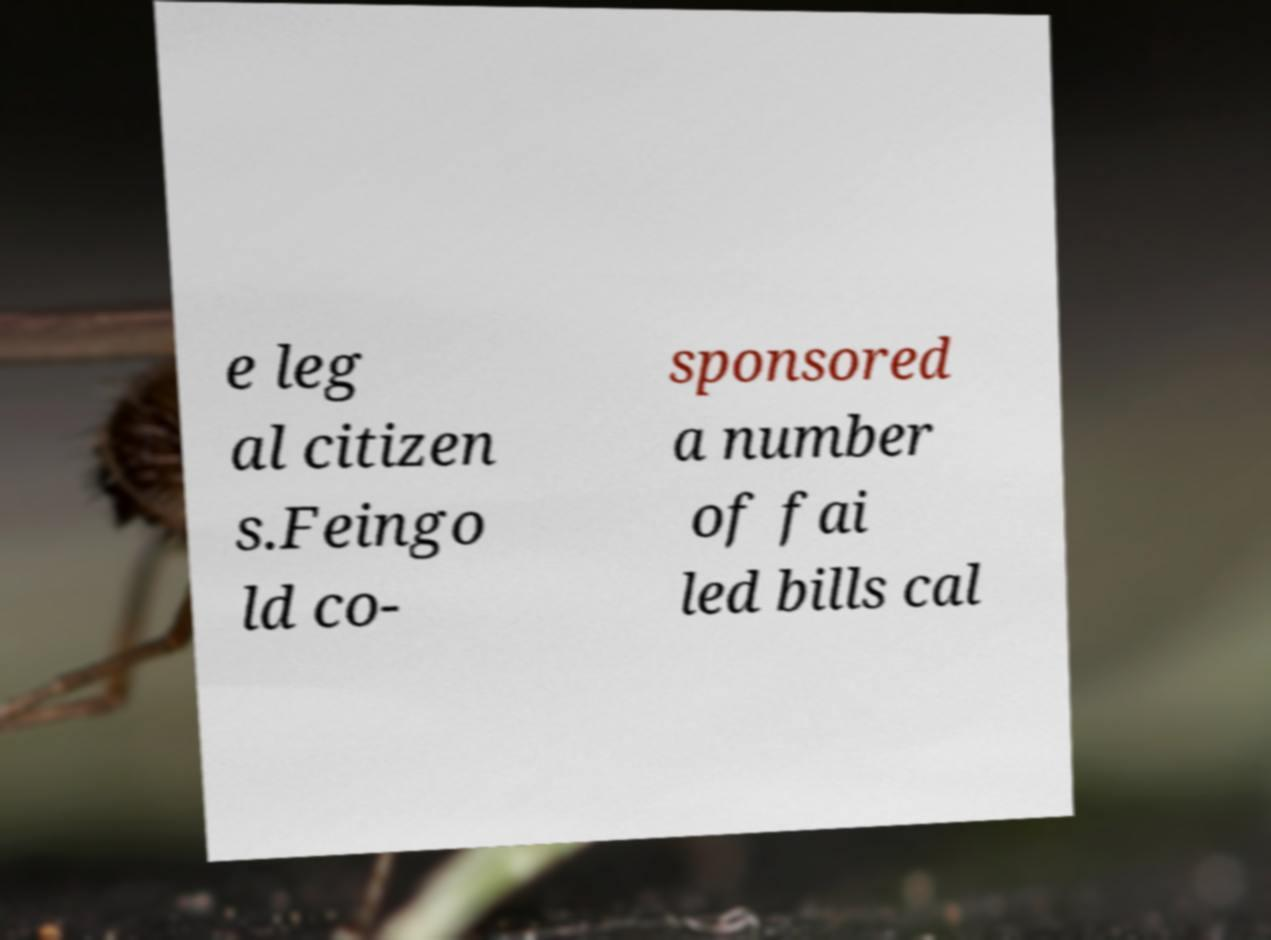For documentation purposes, I need the text within this image transcribed. Could you provide that? e leg al citizen s.Feingo ld co- sponsored a number of fai led bills cal 